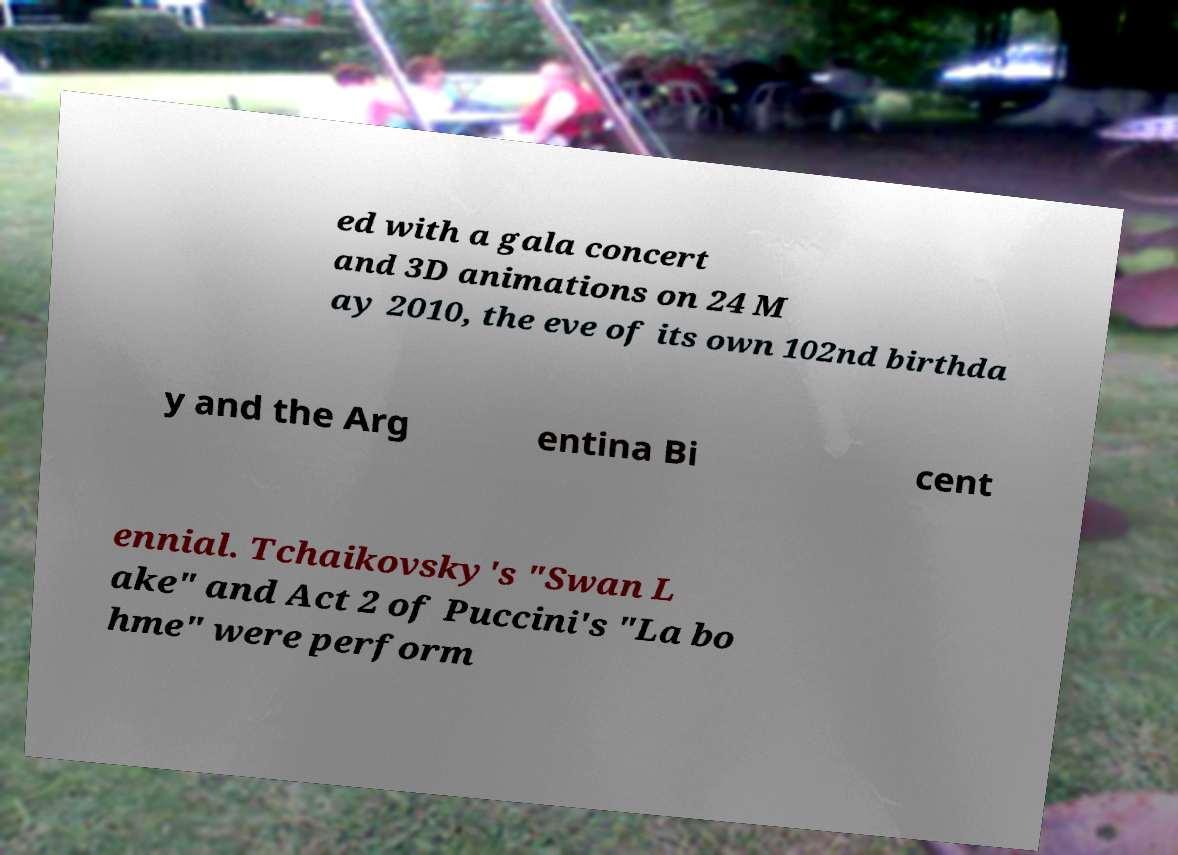There's text embedded in this image that I need extracted. Can you transcribe it verbatim? ed with a gala concert and 3D animations on 24 M ay 2010, the eve of its own 102nd birthda y and the Arg entina Bi cent ennial. Tchaikovsky's "Swan L ake" and Act 2 of Puccini's "La bo hme" were perform 